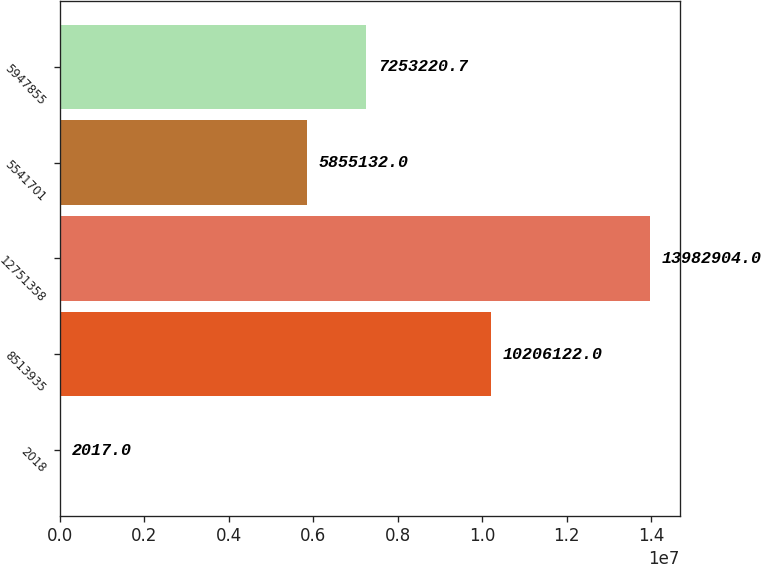Convert chart. <chart><loc_0><loc_0><loc_500><loc_500><bar_chart><fcel>2018<fcel>8513935<fcel>12751358<fcel>5541701<fcel>5947855<nl><fcel>2017<fcel>1.02061e+07<fcel>1.39829e+07<fcel>5.85513e+06<fcel>7.25322e+06<nl></chart> 